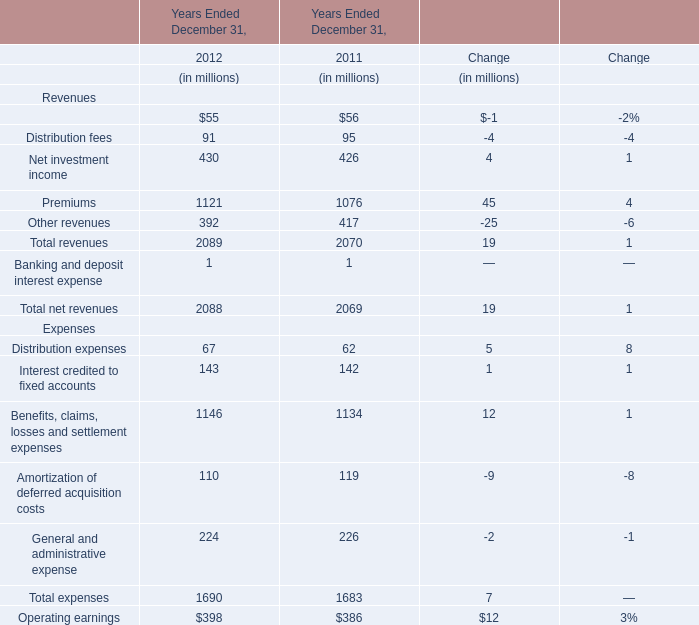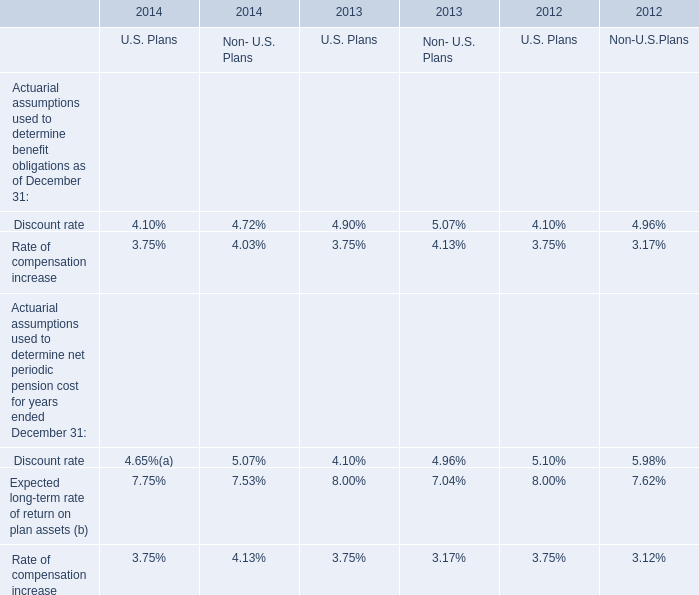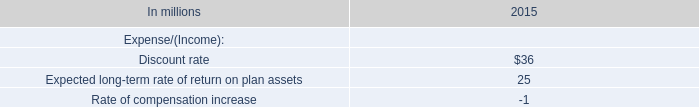How many Revenues keeps increasing between 2012 and 2011? 
Answer: 9. 